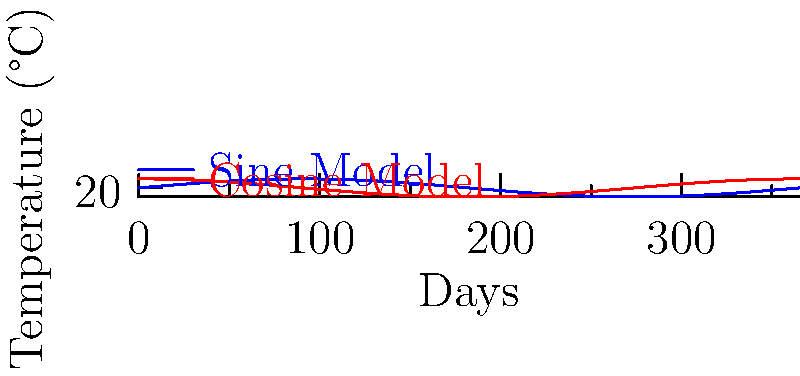In a study of interdisciplinary climate patterns, researchers modeled the average daily temperature T (in °C) of a coastal city over a year using two functions:

1. $T = 5\sin(\frac{2\pi t}{365}) + 20$
2. $T = 5\cos(\frac{2\pi t}{365}) + 20$

Where t represents the day of the year (t = 0 corresponds to January 1st).

Which model more accurately represents the temperature pattern if the city experiences its highest temperatures in mid-July? Explain your reasoning, considering the interdisciplinary nature of climate studies. To determine which model is more accurate, we need to analyze the behavior of sine and cosine functions in the context of annual temperature patterns:

1. Understand the period: Both functions have a period of 365 days, matching a full year.

2. Analyze the amplitude: Both functions have an amplitude of 5°C, with temperatures fluctuating between 15°C and 25°C around the average of 20°C.

3. Compare phase shifts:
   - Sine function: Starts at its middle value and increases.
   - Cosine function: Starts at its maximum value and decreases.

4. Relate to real-world context:
   - Mid-July is approximately day 196 (considering a non-leap year).
   - This is about halfway through the year, corresponding to the peak of the sine function.

5. Interdisciplinary consideration:
   - Climate studies often involve multiple disciplines, including meteorology, oceanography, and data science.
   - The sine function's behavior aligns with the general understanding that temperatures gradually increase from winter to summer in the Northern Hemisphere.

Therefore, the sine function ($T = 5\sin(\frac{2\pi t}{365}) + 20$) more accurately represents the temperature pattern for a city with highest temperatures in mid-July.
Answer: Sine model: $T = 5\sin(\frac{2\pi t}{365}) + 20$ 